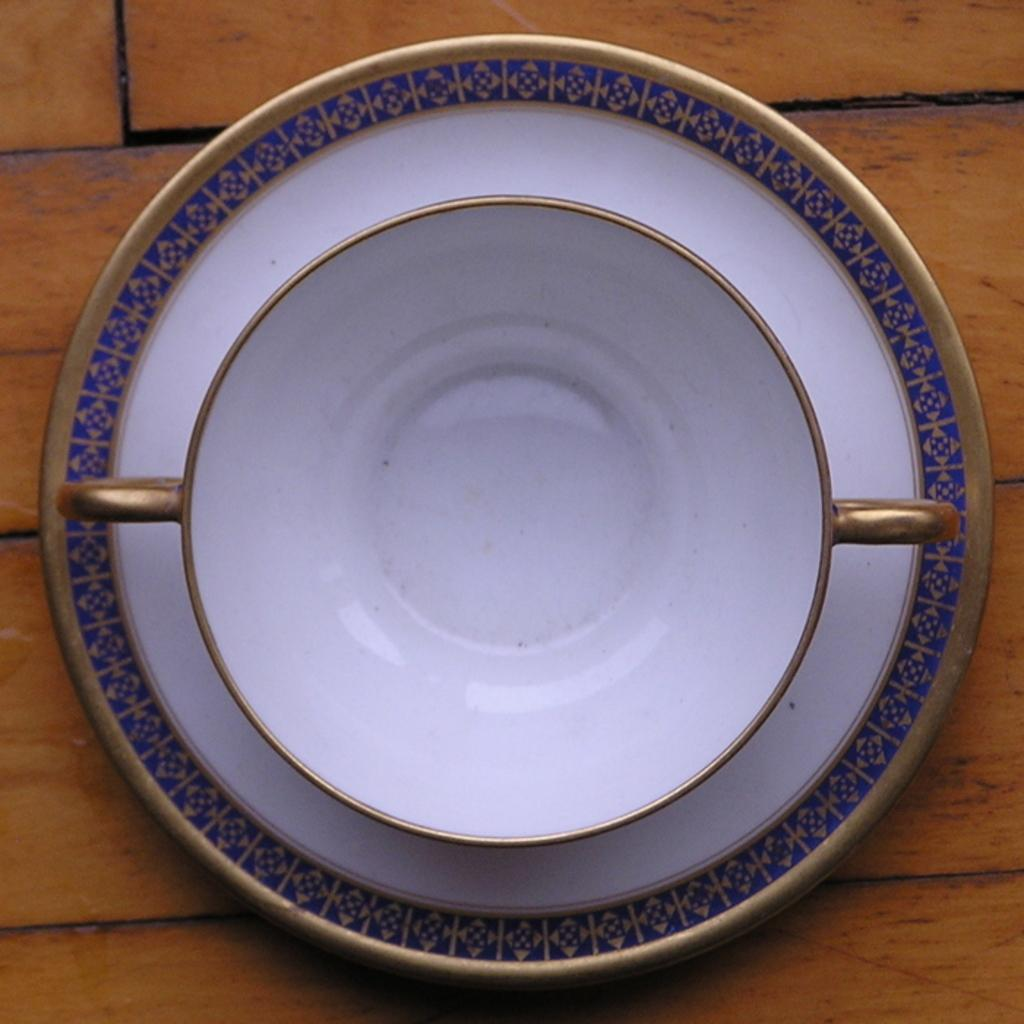What is present on the wooden surface in the image? There is a plate and a bowl on the wooden surface in the image. What is the material of the surface where the plate and bowl are placed? The surface is made of wood. What type of growth can be seen on the wooden surface in the image? There is no growth visible on the wooden surface in the image. What design elements are present on the plate and bowl in the image? The provided facts do not mention any design elements on the plate and bowl, so we cannot answer this question based on the given information. 